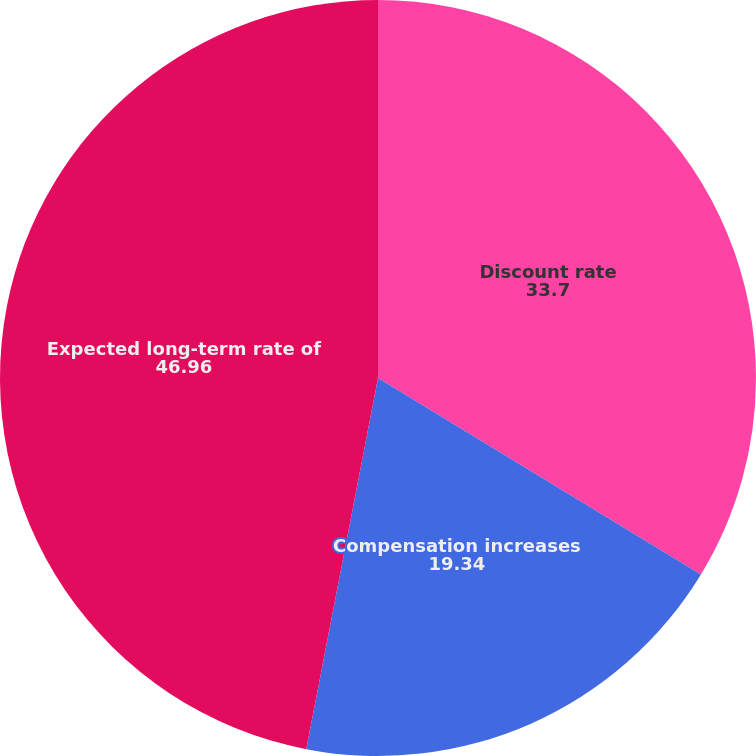<chart> <loc_0><loc_0><loc_500><loc_500><pie_chart><fcel>Discount rate<fcel>Compensation increases<fcel>Expected long-term rate of<nl><fcel>33.7%<fcel>19.34%<fcel>46.96%<nl></chart> 